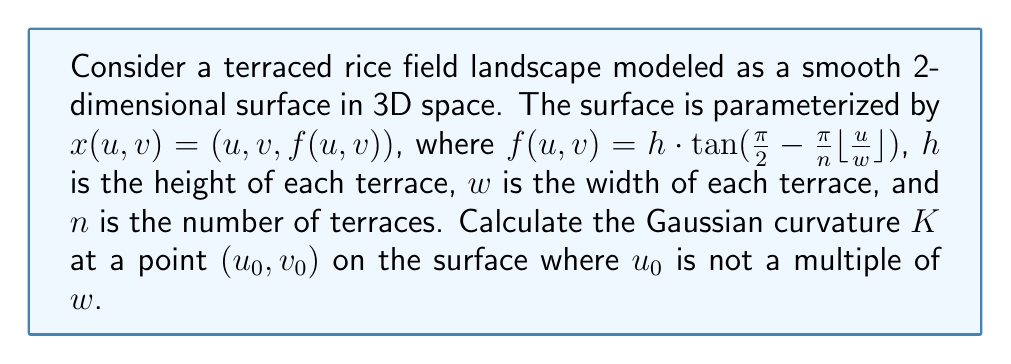Give your solution to this math problem. To calculate the Gaussian curvature, we need to follow these steps:

1) First, we need to calculate the partial derivatives of $x$ with respect to $u$ and $v$:

   $x_u = (1, 0, f_u)$
   $x_v = (0, 1, f_v)$

   Where $f_u = -\frac{h\pi}{nw} \sec^2(\frac{\pi}{2} - \frac{\pi}{n} \lfloor\frac{u}{w}\rfloor)$ and $f_v = 0$

2) Next, we calculate the coefficients of the first fundamental form:

   $E = x_u \cdot x_u = 1 + f_u^2$
   $F = x_u \cdot x_v = 0$
   $G = x_v \cdot x_v = 1$

3) Now, we calculate the second partial derivatives:

   $x_{uu} = (0, 0, f_{uu})$
   $x_{uv} = (0, 0, f_{uv}) = (0, 0, 0)$
   $x_{vv} = (0, 0, f_{vv}) = (0, 0, 0)$

   Where $f_{uu} = -\frac{2h\pi^2}{n^2w^2} \sec^2(\frac{\pi}{2} - \frac{\pi}{n} \lfloor\frac{u}{w}\rfloor) \tan(\frac{\pi}{2} - \frac{\pi}{n} \lfloor\frac{u}{w}\rfloor)$

4) We can now calculate the coefficients of the second fundamental form:

   $L = \frac{x_u \times x_v \cdot x_{uu}}{|x_u \times x_v|} = \frac{f_{uu}}{\sqrt{1 + f_u^2}}$
   $M = \frac{x_u \times x_v \cdot x_{uv}}{|x_u \times x_v|} = 0$
   $N = \frac{x_u \times x_v \cdot x_{vv}}{|x_u \times x_v|} = 0$

5) Finally, we can calculate the Gaussian curvature:

   $K = \frac{LN - M^2}{EG - F^2} = \frac{L \cdot 0 - 0^2}{(1 + f_u^2) \cdot 1 - 0^2} = 0$

Therefore, the Gaussian curvature at any point $(u_0, v_0)$ where $u_0$ is not a multiple of $w$ is zero.
Answer: $K = 0$ 